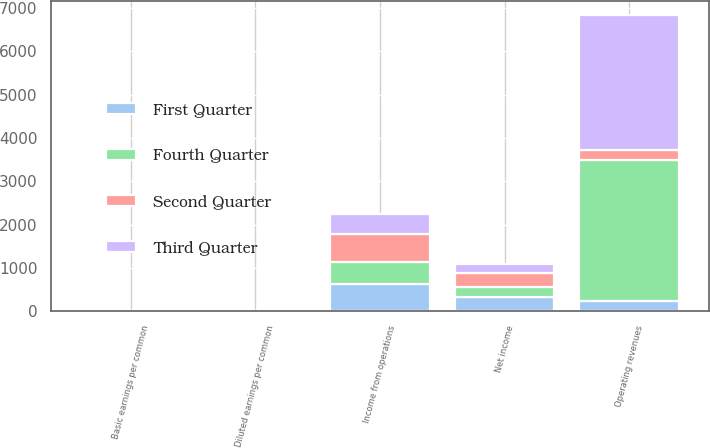<chart> <loc_0><loc_0><loc_500><loc_500><stacked_bar_chart><ecel><fcel>Operating revenues<fcel>Income from operations<fcel>Net income<fcel>Basic earnings per common<fcel>Diluted earnings per common<nl><fcel>Fourth Quarter<fcel>3266<fcel>511<fcel>241<fcel>0.49<fcel>0.48<nl><fcel>First Quarter<fcel>229.5<fcel>632<fcel>318<fcel>0.65<fcel>0.64<nl><fcel>Second Quarter<fcel>229.5<fcel>632<fcel>310<fcel>0.63<fcel>0.63<nl><fcel>Third Quarter<fcel>3108<fcel>459<fcel>218<fcel>0.44<fcel>0.44<nl></chart> 